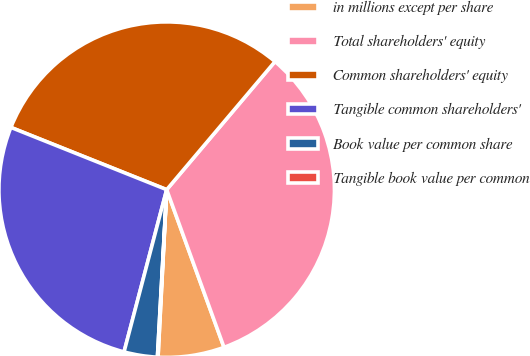<chart> <loc_0><loc_0><loc_500><loc_500><pie_chart><fcel>in millions except per share<fcel>Total shareholders' equity<fcel>Common shareholders' equity<fcel>Tangible common shareholders'<fcel>Book value per common share<fcel>Tangible book value per common<nl><fcel>6.37%<fcel>33.28%<fcel>30.12%<fcel>26.96%<fcel>3.21%<fcel>0.06%<nl></chart> 